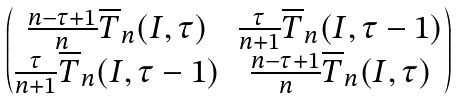<formula> <loc_0><loc_0><loc_500><loc_500>\begin{pmatrix} \frac { n - \tau + 1 } { n } \overline { T } _ { n } ( I , \tau ) & \frac { \tau } { n + 1 } \overline { T } _ { n } ( I , \tau - 1 ) \\ \frac { \tau } { n + 1 } \overline { T } _ { n } ( I , \tau - 1 ) & \frac { n - \tau + 1 } { n } \overline { T } _ { n } ( I , \tau ) \end{pmatrix}</formula> 